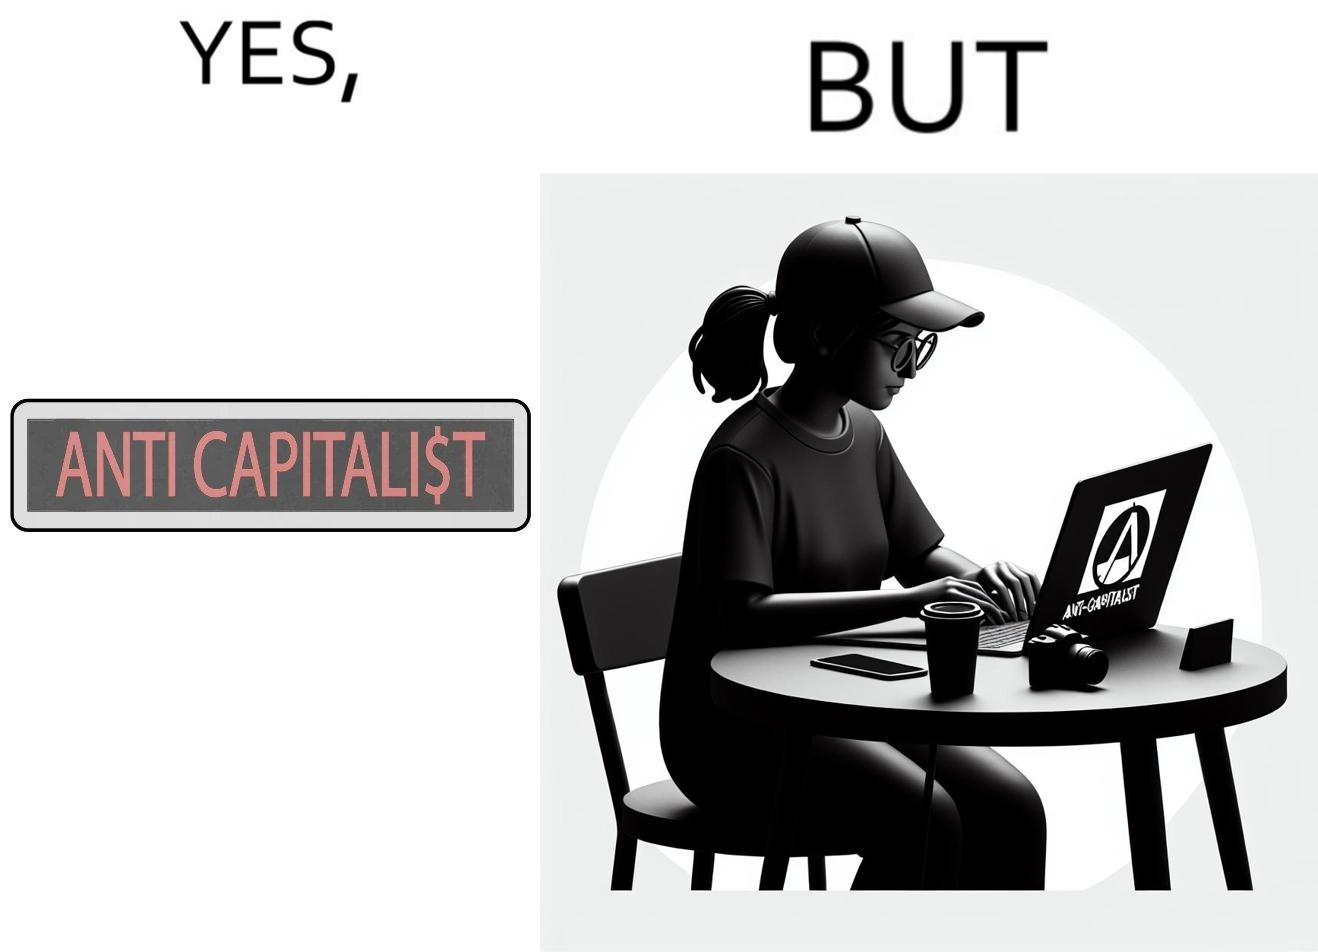Describe what you see in the left and right parts of this image. In the left part of the image: The image is just text with red font saying anti capitalist where the letter s in the capitalist is replaced with the dollar sign. In the right part of the image: A woman wearing glasses and a cap using laptop with the sign anti capitalist on it. The women has a phone, a camera and a cup on the table. She is working. 